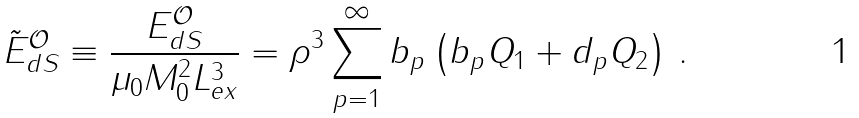Convert formula to latex. <formula><loc_0><loc_0><loc_500><loc_500>\tilde { E } _ { d S } ^ { \mathcal { O } } \equiv \frac { E _ { d S } ^ { \mathcal { O } } } { \mu _ { 0 } M _ { 0 } ^ { 2 } L _ { e x } ^ { 3 } } = \rho ^ { 3 } \sum _ { p = 1 } ^ { \infty } b _ { p } \left ( b _ { p } Q _ { 1 } + d _ { p } Q _ { 2 } \right ) \, .</formula> 